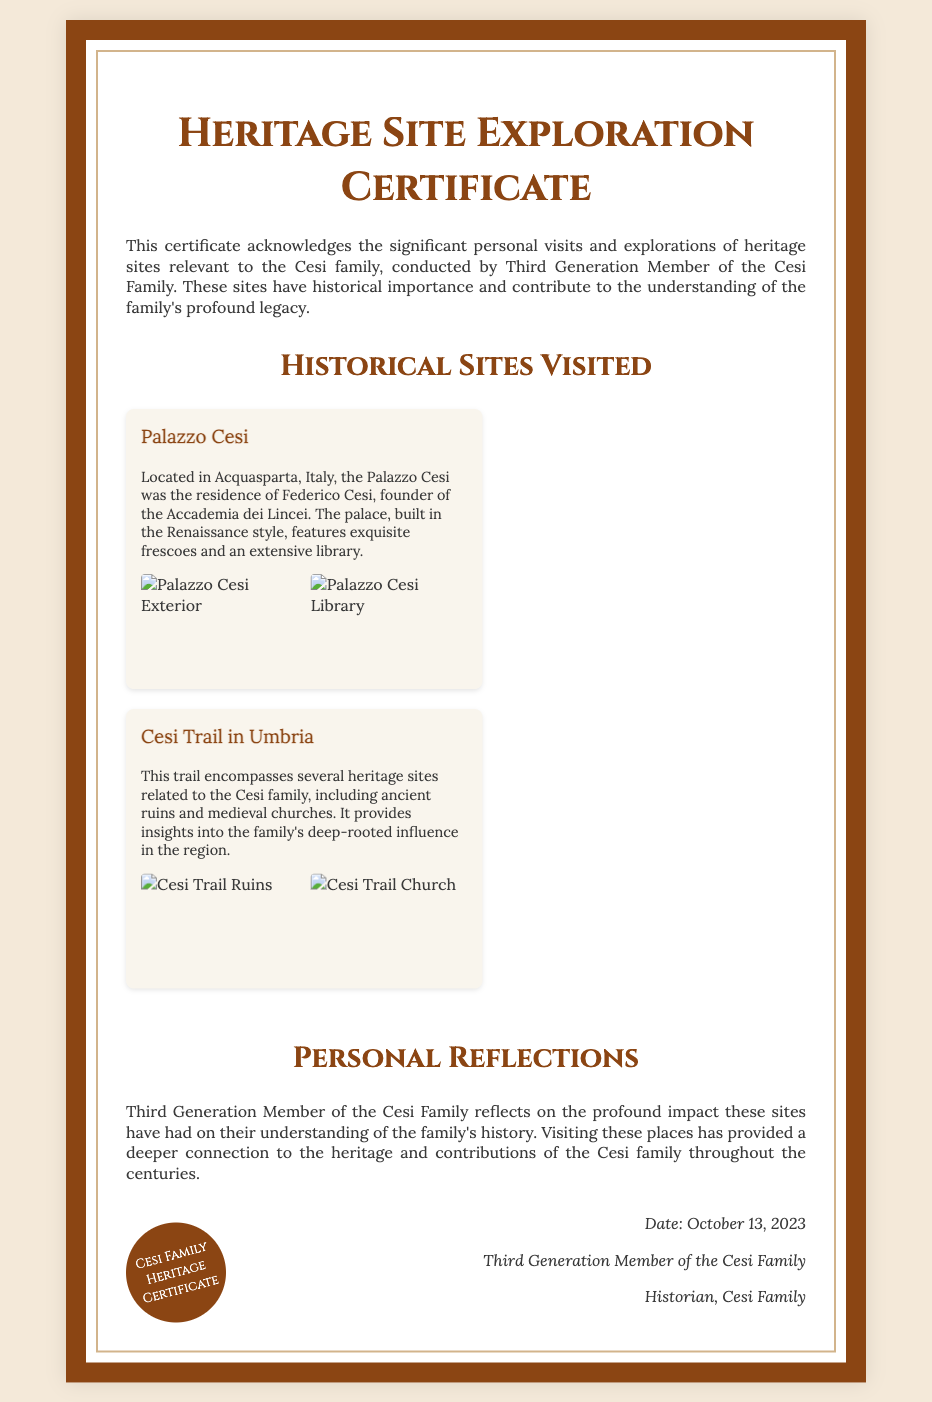What is the title of the certificate? The title can be found at the top of the document, indicating the purpose of the certificate.
Answer: Heritage Site Exploration Certificate What is the name of the historian acknowledged in the certificate? The historian's name appears at the end of the document under the signature section.
Answer: Third Generation Member of the Cesi Family On what date was the certificate issued? The date is mentioned in the signature section of the document.
Answer: October 13, 2023 Which historical site is located in Acquasparta, Italy? The historical site described in the document with its specific location is clearly stated in the section about historical sites visited.
Answer: Palazzo Cesi What was the name of the founder of the Accademia dei Lincei? This information is provided in the description of Palazzo Cesi within the document.
Answer: Federico Cesi How many photographs are included for the Cesi Trail in Umbria? The number of photographs can be inferred from the section dedicated to the Cesi Trail where they are listed.
Answer: 2 What type of sites does the Cesi Trail in Umbria encompass? The document provides a brief description of the type of sites encountered on the trail.
Answer: Ancient ruins and medieval churches What personal insight is shared in the reflection section? The reflection section discusses the impact of visiting heritage sites, indicating a personal experience.
Answer: Deeper connection to the heritage What kind of design style is mentioned for Palazzo Cesi? The architectural style is detailed in the historical description of Palazzo Cesi.
Answer: Renaissance style 